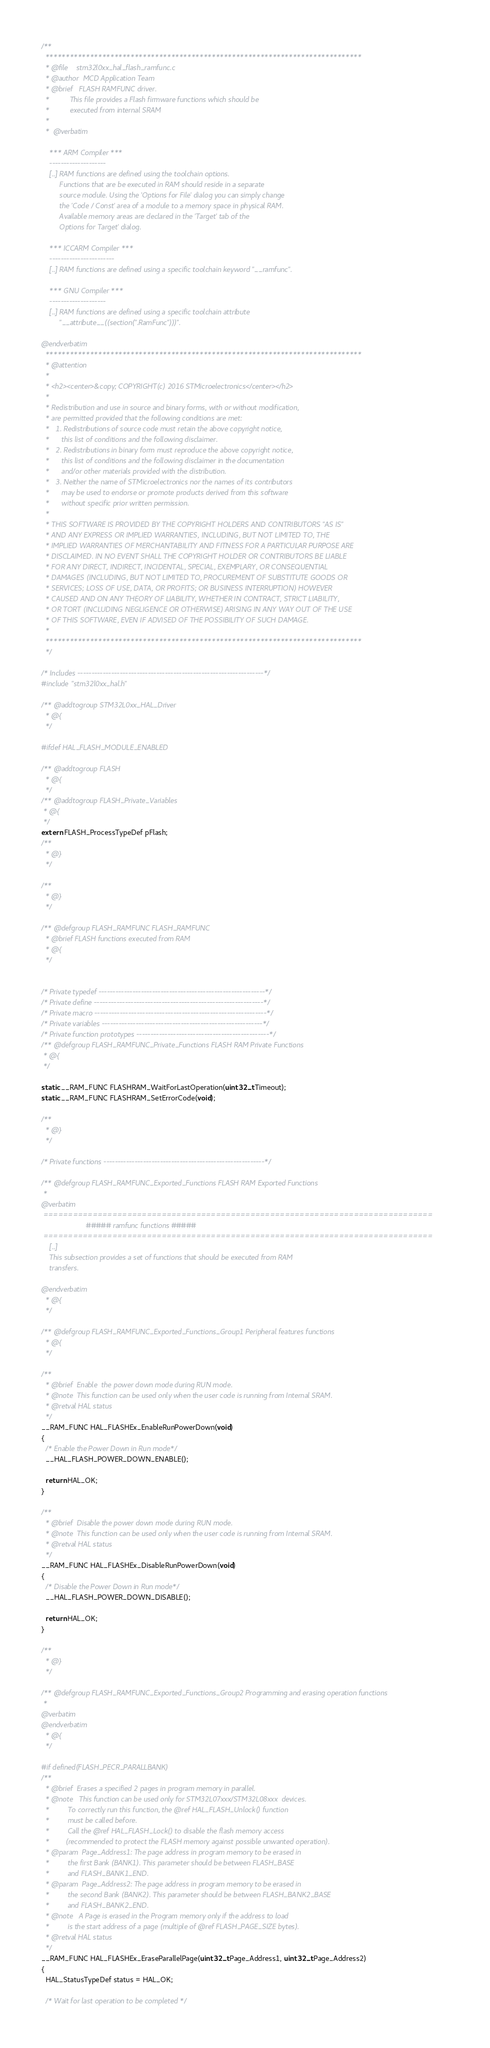Convert code to text. <code><loc_0><loc_0><loc_500><loc_500><_C_>/**
  ******************************************************************************
  * @file    stm32l0xx_hal_flash_ramfunc.c
  * @author  MCD Application Team
  * @brief   FLASH RAMFUNC driver.
  *          This file provides a Flash firmware functions which should be 
  *          executed from internal SRAM
  *
  *  @verbatim

    *** ARM Compiler ***
    --------------------
    [..] RAM functions are defined using the toolchain options. 
         Functions that are be executed in RAM should reside in a separate
         source module. Using the 'Options for File' dialog you can simply change
         the 'Code / Const' area of a module to a memory space in physical RAM.
         Available memory areas are declared in the 'Target' tab of the 
         Options for Target' dialog.

    *** ICCARM Compiler ***
    -----------------------
    [..] RAM functions are defined using a specific toolchain keyword "__ramfunc".

    *** GNU Compiler ***
    --------------------
    [..] RAM functions are defined using a specific toolchain attribute
         "__attribute__((section(".RamFunc")))".

@endverbatim
  ******************************************************************************
  * @attention
  *
  * <h2><center>&copy; COPYRIGHT(c) 2016 STMicroelectronics</center></h2>
  *
  * Redistribution and use in source and binary forms, with or without modification,
  * are permitted provided that the following conditions are met:
  *   1. Redistributions of source code must retain the above copyright notice,
  *      this list of conditions and the following disclaimer.
  *   2. Redistributions in binary form must reproduce the above copyright notice,
  *      this list of conditions and the following disclaimer in the documentation
  *      and/or other materials provided with the distribution.
  *   3. Neither the name of STMicroelectronics nor the names of its contributors
  *      may be used to endorse or promote products derived from this software
  *      without specific prior written permission.
  *
  * THIS SOFTWARE IS PROVIDED BY THE COPYRIGHT HOLDERS AND CONTRIBUTORS "AS IS"
  * AND ANY EXPRESS OR IMPLIED WARRANTIES, INCLUDING, BUT NOT LIMITED TO, THE
  * IMPLIED WARRANTIES OF MERCHANTABILITY AND FITNESS FOR A PARTICULAR PURPOSE ARE
  * DISCLAIMED. IN NO EVENT SHALL THE COPYRIGHT HOLDER OR CONTRIBUTORS BE LIABLE
  * FOR ANY DIRECT, INDIRECT, INCIDENTAL, SPECIAL, EXEMPLARY, OR CONSEQUENTIAL
  * DAMAGES (INCLUDING, BUT NOT LIMITED TO, PROCUREMENT OF SUBSTITUTE GOODS OR
  * SERVICES; LOSS OF USE, DATA, OR PROFITS; OR BUSINESS INTERRUPTION) HOWEVER
  * CAUSED AND ON ANY THEORY OF LIABILITY, WHETHER IN CONTRACT, STRICT LIABILITY,
  * OR TORT (INCLUDING NEGLIGENCE OR OTHERWISE) ARISING IN ANY WAY OUT OF THE USE
  * OF THIS SOFTWARE, EVEN IF ADVISED OF THE POSSIBILITY OF SUCH DAMAGE.
  *
  ******************************************************************************
  */

/* Includes ------------------------------------------------------------------*/
#include "stm32l0xx_hal.h"

/** @addtogroup STM32L0xx_HAL_Driver
  * @{
  */

#ifdef HAL_FLASH_MODULE_ENABLED

/** @addtogroup FLASH
  * @{
  */
/** @addtogroup FLASH_Private_Variables
 * @{
 */
extern FLASH_ProcessTypeDef pFlash;
/**
  * @}
  */

/**
  * @}
  */
  
/** @defgroup FLASH_RAMFUNC FLASH_RAMFUNC
  * @brief FLASH functions executed from RAM
  * @{
  */ 


/* Private typedef -----------------------------------------------------------*/
/* Private define ------------------------------------------------------------*/
/* Private macro -------------------------------------------------------------*/
/* Private variables ---------------------------------------------------------*/
/* Private function prototypes -----------------------------------------------*/
/** @defgroup FLASH_RAMFUNC_Private_Functions FLASH RAM Private Functions
 * @{
 */

static __RAM_FUNC FLASHRAM_WaitForLastOperation(uint32_t Timeout);
static __RAM_FUNC FLASHRAM_SetErrorCode(void);

/**
  * @}
  */

/* Private functions ---------------------------------------------------------*/
 
/** @defgroup FLASH_RAMFUNC_Exported_Functions FLASH RAM Exported Functions
 *
@verbatim  
 ===============================================================================
                      ##### ramfunc functions #####
 ===============================================================================  
    [..]
    This subsection provides a set of functions that should be executed from RAM 
    transfers.

@endverbatim
  * @{
  */ 

/** @defgroup FLASH_RAMFUNC_Exported_Functions_Group1 Peripheral features functions 
  * @{
  */  

/**
  * @brief  Enable  the power down mode during RUN mode.
  * @note  This function can be used only when the user code is running from Internal SRAM.
  * @retval HAL status
  */
__RAM_FUNC HAL_FLASHEx_EnableRunPowerDown(void)
{
  /* Enable the Power Down in Run mode*/
  __HAL_FLASH_POWER_DOWN_ENABLE();

  return HAL_OK;
}

/**
  * @brief  Disable the power down mode during RUN mode.
  * @note  This function can be used only when the user code is running from Internal SRAM.
  * @retval HAL status
  */
__RAM_FUNC HAL_FLASHEx_DisableRunPowerDown(void)
{
  /* Disable the Power Down in Run mode*/
  __HAL_FLASH_POWER_DOWN_DISABLE();

  return HAL_OK;  
}

/**
  * @}
  */

/** @defgroup FLASH_RAMFUNC_Exported_Functions_Group2 Programming and erasing operation functions 
 *
@verbatim  
@endverbatim
  * @{
  */

#if defined(FLASH_PECR_PARALLBANK)
/**
  * @brief  Erases a specified 2 pages in program memory in parallel.
  * @note   This function can be used only for STM32L07xxx/STM32L08xxx  devices.
  *         To correctly run this function, the @ref HAL_FLASH_Unlock() function
  *         must be called before.
  *         Call the @ref HAL_FLASH_Lock() to disable the flash memory access 
  *        (recommended to protect the FLASH memory against possible unwanted operation).
  * @param  Page_Address1: The page address in program memory to be erased in 
  *         the first Bank (BANK1). This parameter should be between FLASH_BASE
  *         and FLASH_BANK1_END.
  * @param  Page_Address2: The page address in program memory to be erased in 
  *         the second Bank (BANK2). This parameter should be between FLASH_BANK2_BASE
  *         and FLASH_BANK2_END.
  * @note   A Page is erased in the Program memory only if the address to load 
  *         is the start address of a page (multiple of @ref FLASH_PAGE_SIZE bytes).
  * @retval HAL status
  */
__RAM_FUNC HAL_FLASHEx_EraseParallelPage(uint32_t Page_Address1, uint32_t Page_Address2)
{
  HAL_StatusTypeDef status = HAL_OK;

  /* Wait for last operation to be completed */</code> 